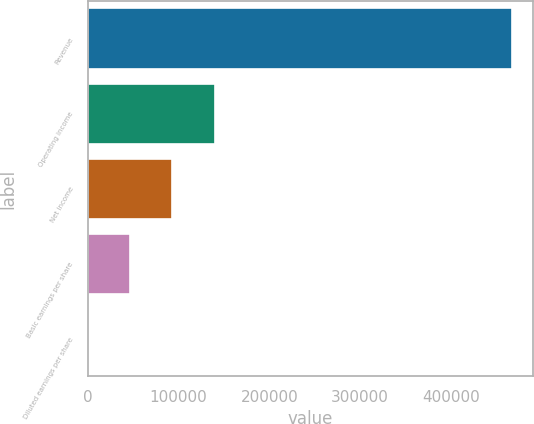<chart> <loc_0><loc_0><loc_500><loc_500><bar_chart><fcel>Revenue<fcel>Operating income<fcel>Net income<fcel>Basic earnings per share<fcel>Diluted earnings per share<nl><fcel>466841<fcel>140053<fcel>93369.4<fcel>46685.4<fcel>1.46<nl></chart> 